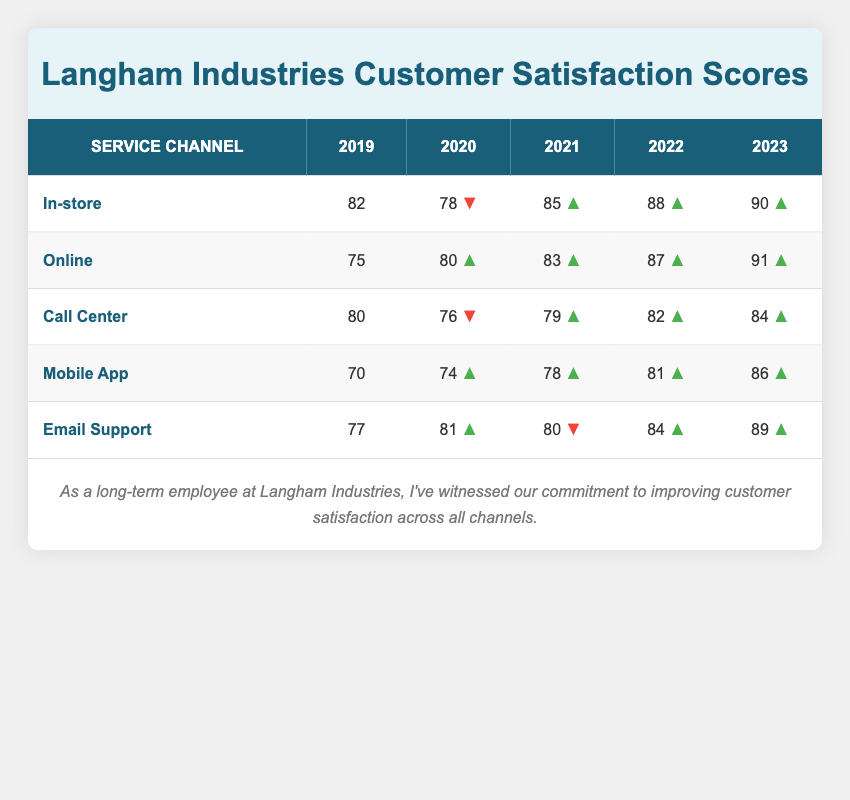What was the customer satisfaction score for the Call Center in 2020? The table indicates that the customer satisfaction score for the Call Center in 2020 is shown in the row corresponding to the Call Center and the column labeled 2020. The value is 76.
Answer: 76 Which service channel had the highest score in 2023? By comparing the scores in the row for each service channel under the column for the year 2023, it's evident that the Online channel had the highest score with a value of 91.
Answer: Online What is the average customer satisfaction score for Email Support over the five years? To find the average, sum the satisfaction scores from 2019 to 2023: 77 + 81 + 80 + 84 + 89 = 411. There are 5 data points, so the average is 411 divided by 5, which equals 82.2.
Answer: 82.2 Did the satisfaction score for the Mobile App increase every year? By examining the Mobile App row across the years, each succeeding score is higher than the previous year: 70, 74, 78, 81, and 86. Therefore, it is true that the score increased every year.
Answer: Yes Which service channel experienced a decrease in satisfaction score from 2019 to 2020? Looking at the scores for each channel, the In-store channel decreased from 82 in 2019 to 78 in 2020. The Call Center also decreased from 80 to 76. Therefore, both these channels experienced a decrease.
Answer: In-store, Call Center What was the change in customer satisfaction score for Online from 2019 to 2023? The score for Online in 2019 was 75, and by 2023 it increased to 91. To find the change, subtract the 2019 score from the 2023 score: 91 - 75 = 16. Thus, the change was an increase of 16 points.
Answer: 16 Is the customer satisfaction score for Call Center in 2022 higher than that for Email Support in 2022? The score for the Call Center in 2022 is 82 and for Email Support, it is 84. Since 82 is less than 84, the statement is false.
Answer: No What was the overall trend in satisfaction scores for the In-store channel across the five years? The scores for the In-store channel are 82, 78, 85, 88, and 90, indicating a drop in 2020 followed by increases in each subsequent year. Overall, the latter years showed positive growth after the decline.
Answer: Overall increase after a dip in 2020 